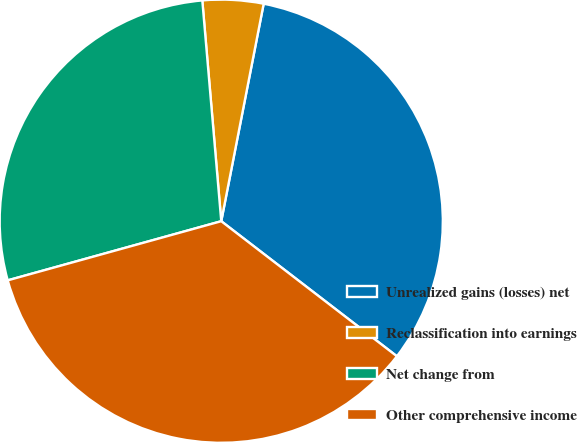Convert chart to OTSL. <chart><loc_0><loc_0><loc_500><loc_500><pie_chart><fcel>Unrealized gains (losses) net<fcel>Reclassification into earnings<fcel>Net change from<fcel>Other comprehensive income<nl><fcel>32.37%<fcel>4.43%<fcel>27.94%<fcel>35.27%<nl></chart> 